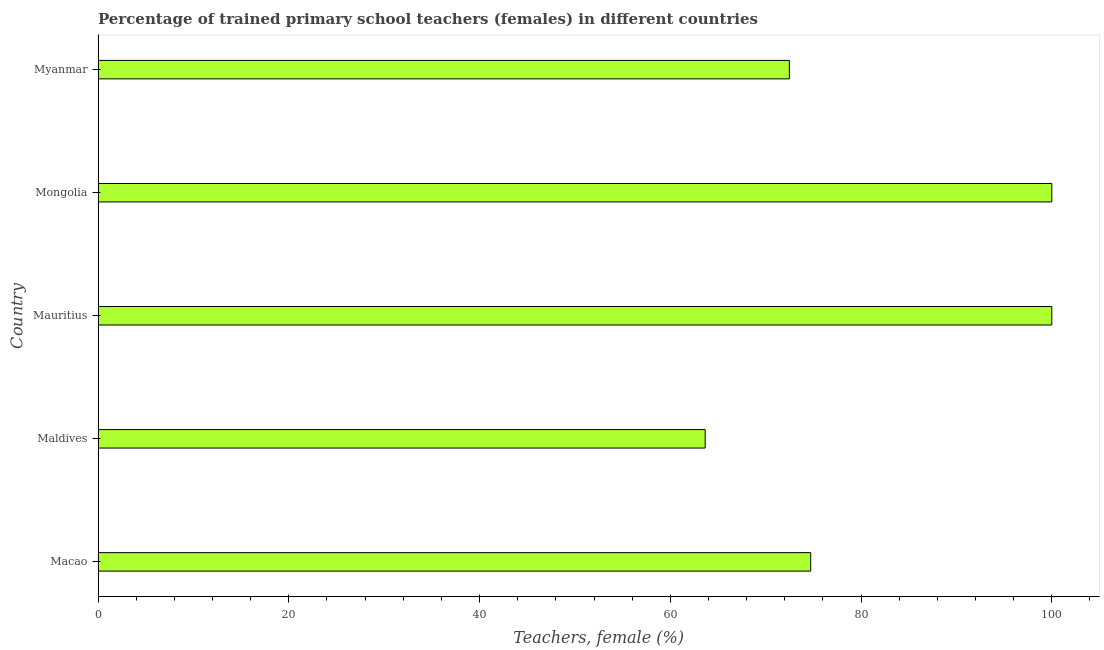Does the graph contain any zero values?
Keep it short and to the point. No. What is the title of the graph?
Make the answer very short. Percentage of trained primary school teachers (females) in different countries. What is the label or title of the X-axis?
Offer a terse response. Teachers, female (%). What is the label or title of the Y-axis?
Give a very brief answer. Country. What is the percentage of trained female teachers in Myanmar?
Offer a very short reply. 72.48. Across all countries, what is the minimum percentage of trained female teachers?
Your response must be concise. 63.66. In which country was the percentage of trained female teachers maximum?
Give a very brief answer. Mauritius. In which country was the percentage of trained female teachers minimum?
Give a very brief answer. Maldives. What is the sum of the percentage of trained female teachers?
Give a very brief answer. 410.86. What is the difference between the percentage of trained female teachers in Macao and Myanmar?
Offer a very short reply. 2.23. What is the average percentage of trained female teachers per country?
Give a very brief answer. 82.17. What is the median percentage of trained female teachers?
Your answer should be very brief. 74.72. What is the ratio of the percentage of trained female teachers in Maldives to that in Myanmar?
Keep it short and to the point. 0.88. Is the difference between the percentage of trained female teachers in Mauritius and Mongolia greater than the difference between any two countries?
Offer a very short reply. No. What is the difference between the highest and the second highest percentage of trained female teachers?
Provide a short and direct response. 0. What is the difference between the highest and the lowest percentage of trained female teachers?
Your answer should be compact. 36.34. In how many countries, is the percentage of trained female teachers greater than the average percentage of trained female teachers taken over all countries?
Your response must be concise. 2. How many countries are there in the graph?
Offer a very short reply. 5. What is the difference between two consecutive major ticks on the X-axis?
Offer a very short reply. 20. Are the values on the major ticks of X-axis written in scientific E-notation?
Provide a short and direct response. No. What is the Teachers, female (%) of Macao?
Ensure brevity in your answer.  74.72. What is the Teachers, female (%) in Maldives?
Offer a very short reply. 63.66. What is the Teachers, female (%) of Mauritius?
Keep it short and to the point. 100. What is the Teachers, female (%) of Myanmar?
Offer a very short reply. 72.48. What is the difference between the Teachers, female (%) in Macao and Maldives?
Your answer should be compact. 11.06. What is the difference between the Teachers, female (%) in Macao and Mauritius?
Ensure brevity in your answer.  -25.28. What is the difference between the Teachers, female (%) in Macao and Mongolia?
Your answer should be very brief. -25.28. What is the difference between the Teachers, female (%) in Macao and Myanmar?
Make the answer very short. 2.23. What is the difference between the Teachers, female (%) in Maldives and Mauritius?
Offer a terse response. -36.34. What is the difference between the Teachers, female (%) in Maldives and Mongolia?
Offer a terse response. -36.34. What is the difference between the Teachers, female (%) in Maldives and Myanmar?
Give a very brief answer. -8.83. What is the difference between the Teachers, female (%) in Mauritius and Mongolia?
Offer a terse response. 0. What is the difference between the Teachers, female (%) in Mauritius and Myanmar?
Your answer should be compact. 27.52. What is the difference between the Teachers, female (%) in Mongolia and Myanmar?
Make the answer very short. 27.52. What is the ratio of the Teachers, female (%) in Macao to that in Maldives?
Make the answer very short. 1.17. What is the ratio of the Teachers, female (%) in Macao to that in Mauritius?
Make the answer very short. 0.75. What is the ratio of the Teachers, female (%) in Macao to that in Mongolia?
Give a very brief answer. 0.75. What is the ratio of the Teachers, female (%) in Macao to that in Myanmar?
Your answer should be very brief. 1.03. What is the ratio of the Teachers, female (%) in Maldives to that in Mauritius?
Your answer should be compact. 0.64. What is the ratio of the Teachers, female (%) in Maldives to that in Mongolia?
Provide a succinct answer. 0.64. What is the ratio of the Teachers, female (%) in Maldives to that in Myanmar?
Your answer should be very brief. 0.88. What is the ratio of the Teachers, female (%) in Mauritius to that in Myanmar?
Your response must be concise. 1.38. What is the ratio of the Teachers, female (%) in Mongolia to that in Myanmar?
Provide a short and direct response. 1.38. 